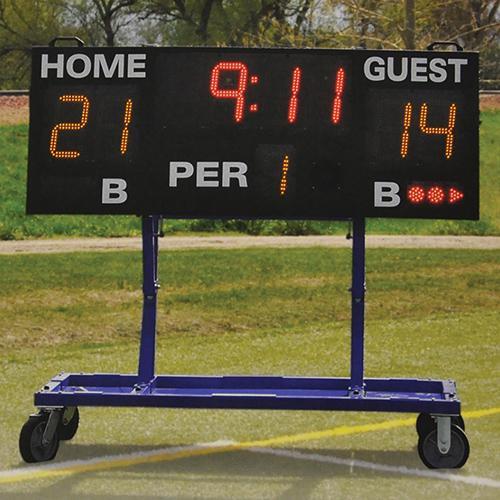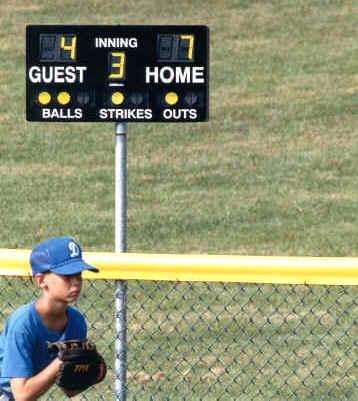The first image is the image on the left, the second image is the image on the right. For the images shown, is this caption "There are two scoreboards which list the home score on the left side and the guest score on the right side." true? Answer yes or no. No. The first image is the image on the left, the second image is the image on the right. Considering the images on both sides, is "The sum of each individual digit visible in both image is less than forty two." valid? Answer yes or no. Yes. 